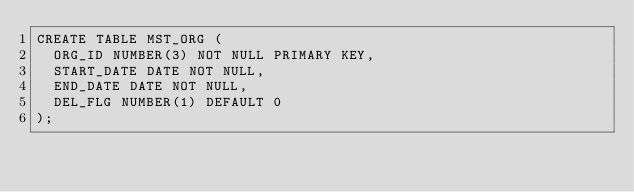<code> <loc_0><loc_0><loc_500><loc_500><_SQL_>CREATE TABLE MST_ORG (
  ORG_ID NUMBER(3) NOT NULL PRIMARY KEY,
  START_DATE DATE NOT NULL,
  END_DATE DATE NOT NULL,
  DEL_FLG NUMBER(1) DEFAULT 0
);</code> 